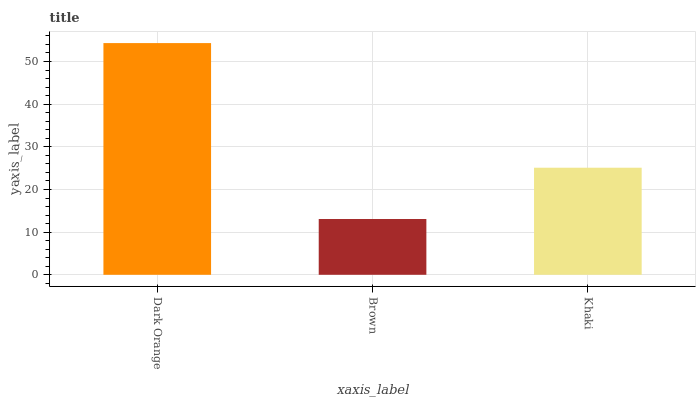Is Brown the minimum?
Answer yes or no. Yes. Is Dark Orange the maximum?
Answer yes or no. Yes. Is Khaki the minimum?
Answer yes or no. No. Is Khaki the maximum?
Answer yes or no. No. Is Khaki greater than Brown?
Answer yes or no. Yes. Is Brown less than Khaki?
Answer yes or no. Yes. Is Brown greater than Khaki?
Answer yes or no. No. Is Khaki less than Brown?
Answer yes or no. No. Is Khaki the high median?
Answer yes or no. Yes. Is Khaki the low median?
Answer yes or no. Yes. Is Dark Orange the high median?
Answer yes or no. No. Is Brown the low median?
Answer yes or no. No. 